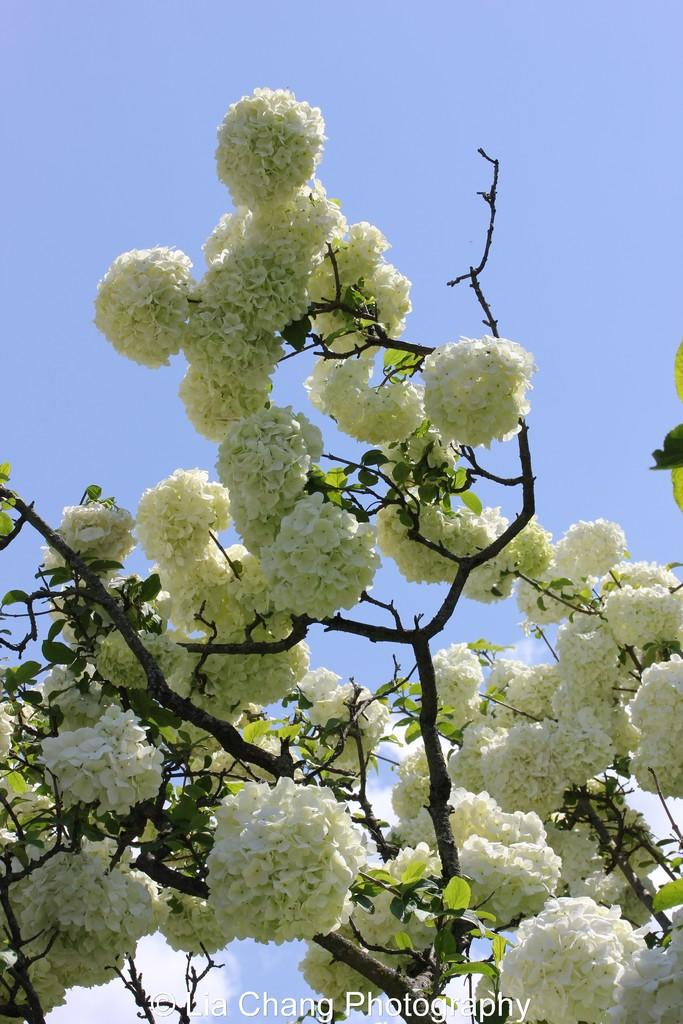What type of flowers can be seen on the plant in the image? There are white flowers on a plant in the image. What else is present at the bottom of the image? There is some text at the bottom of the image. What can be seen in the background of the image? The sky is visible in the background of the image. What type of bottle is visible on the wall in the image? There is no bottle or wall present in the image; it features white flowers on a plant and some text at the bottom. 